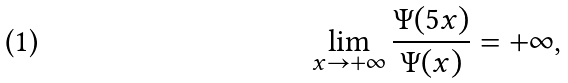Convert formula to latex. <formula><loc_0><loc_0><loc_500><loc_500>\lim _ { x \to + \infty } \frac { \Psi ( 5 x ) } { \Psi ( x ) } = + \infty ,</formula> 